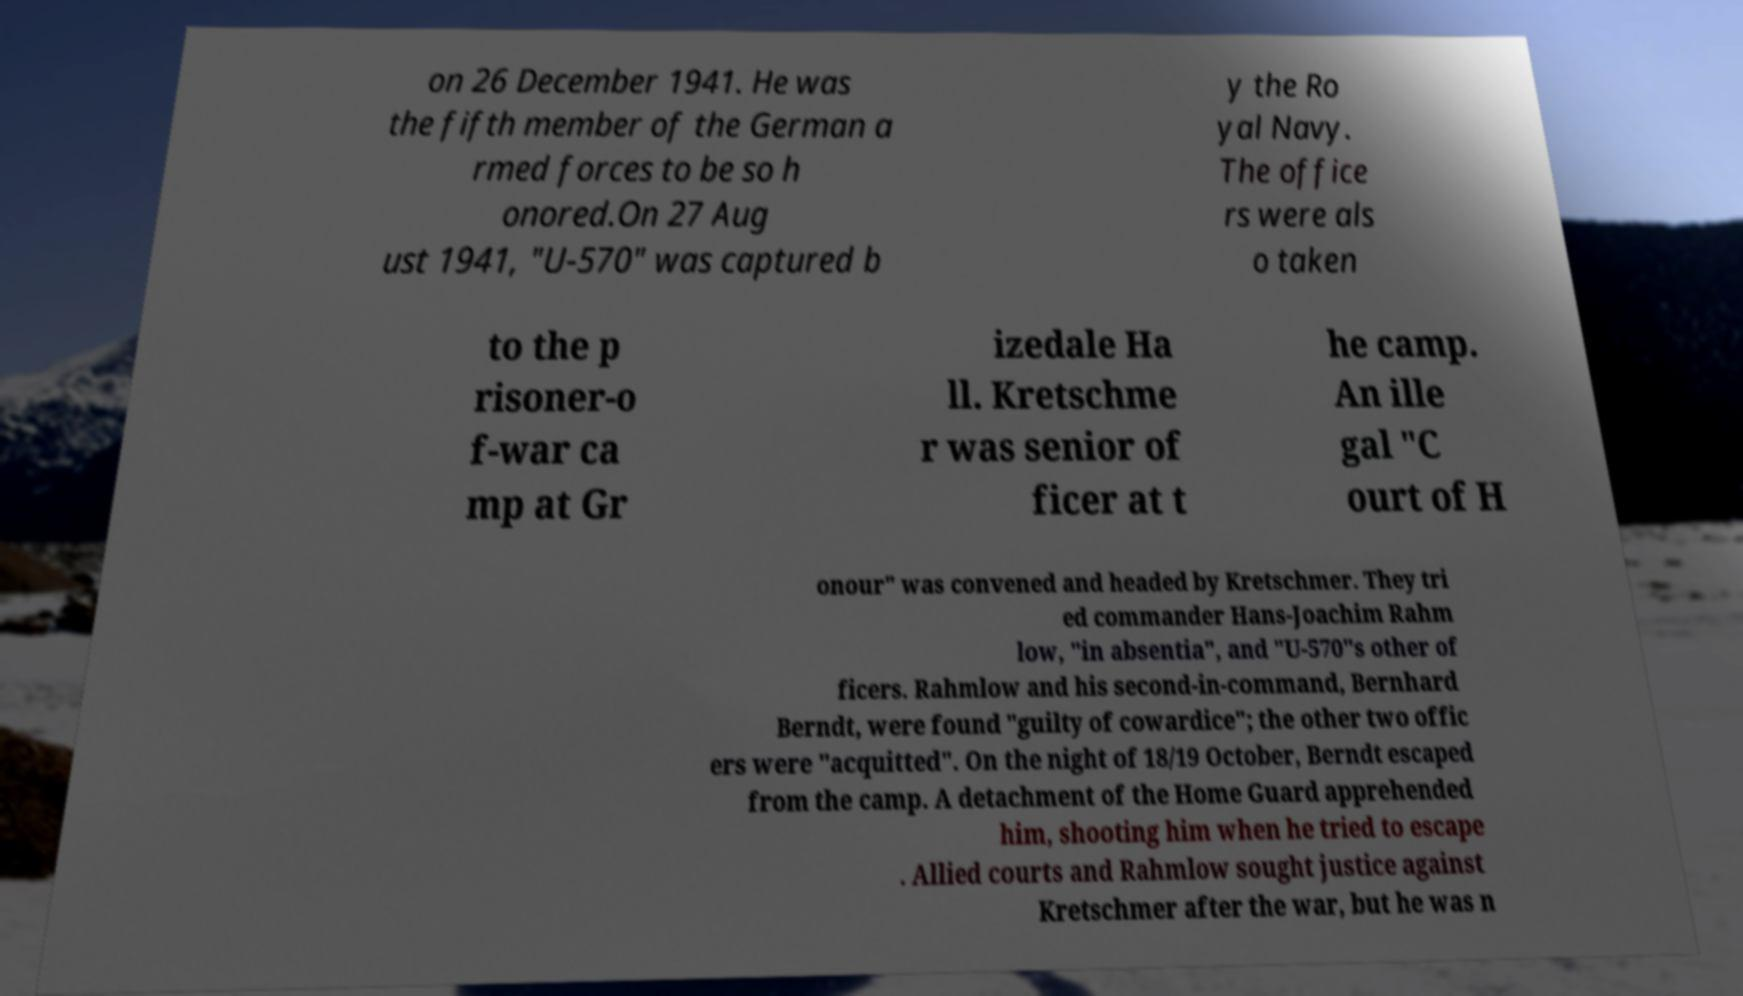I need the written content from this picture converted into text. Can you do that? on 26 December 1941. He was the fifth member of the German a rmed forces to be so h onored.On 27 Aug ust 1941, "U-570" was captured b y the Ro yal Navy. The office rs were als o taken to the p risoner-o f-war ca mp at Gr izedale Ha ll. Kretschme r was senior of ficer at t he camp. An ille gal "C ourt of H onour" was convened and headed by Kretschmer. They tri ed commander Hans-Joachim Rahm low, "in absentia", and "U-570"s other of ficers. Rahmlow and his second-in-command, Bernhard Berndt, were found "guilty of cowardice"; the other two offic ers were "acquitted". On the night of 18/19 October, Berndt escaped from the camp. A detachment of the Home Guard apprehended him, shooting him when he tried to escape . Allied courts and Rahmlow sought justice against Kretschmer after the war, but he was n 